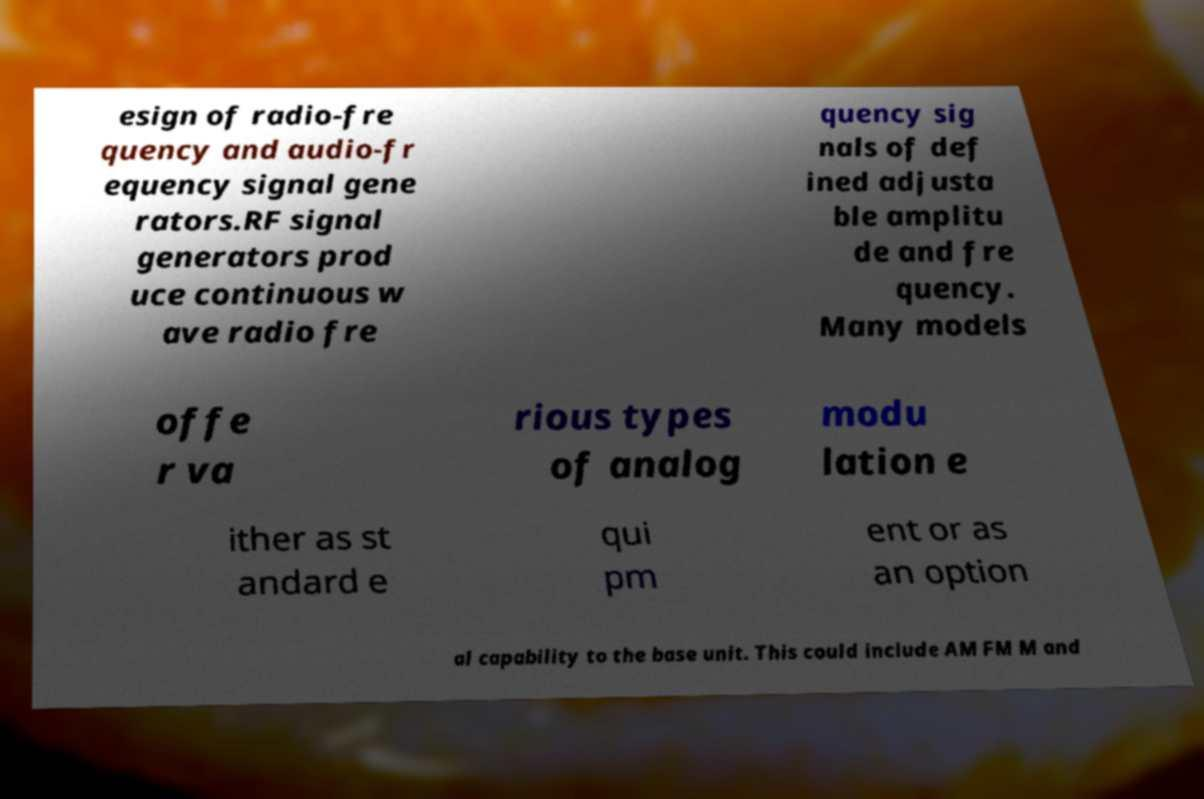Could you assist in decoding the text presented in this image and type it out clearly? esign of radio-fre quency and audio-fr equency signal gene rators.RF signal generators prod uce continuous w ave radio fre quency sig nals of def ined adjusta ble amplitu de and fre quency. Many models offe r va rious types of analog modu lation e ither as st andard e qui pm ent or as an option al capability to the base unit. This could include AM FM M and 